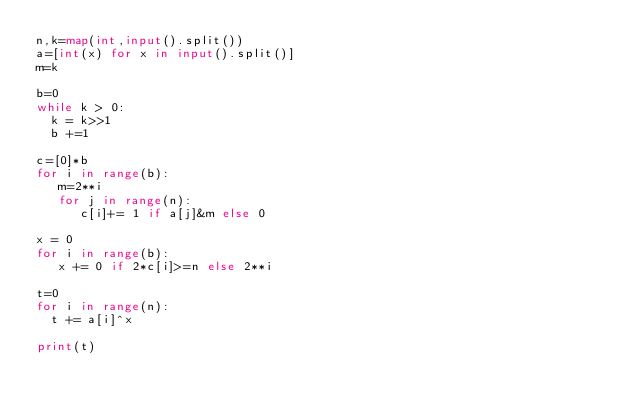<code> <loc_0><loc_0><loc_500><loc_500><_Python_>n,k=map(int,input().split())
a=[int(x) for x in input().split()]
m=k

b=0
while k > 0:
  k = k>>1
  b +=1

c=[0]*b
for i in range(b):
   m=2**i
   for j in range(n):
      c[i]+= 1 if a[j]&m else 0

x = 0
for i in range(b):
   x += 0 if 2*c[i]>=n else 2**i

t=0
for i in range(n):
  t += a[i]^x

print(t)
</code> 